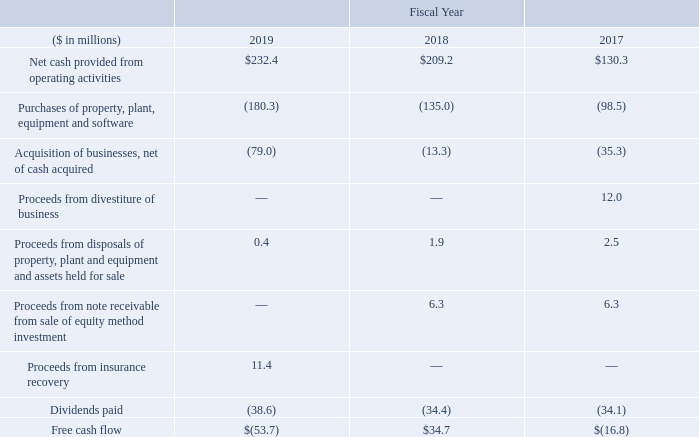Free Cash Flow
The following provides a reconciliation of free cash flow, as used in this annual report, to its most directly comparable U.S. GAAP financial measures:
Management believes that the free cash flow measure provides useful information to investors regarding our financial condition because it is a measure of cash generated which management evaluates for alternative uses. It is management’s current intention to use excess cash to fund investments in capital equipment, acquisition opportunities and consistent dividend payments. Free cash flow is not a U.S. GAAP financial measure and should not be considered in isolation of, or as a substitute for, cash flows calculated in accordance with U.S. GAAP.
What was the Proceeds from insurance recovery in 2019?
Answer scale should be: million. 11.4. What does management believe the free cash flow measure provides? Useful information to investors regarding our financial condition because it is a measure of cash generated which management evaluates for alternative uses. In which years was free cash flow calculated? 2019, 2018, 2017. In which year was the Proceeds from disposals of property, plant and equipment and assets held for sale largest? 2.5>1.9>0.4
Answer: 2017. What was the change in Net cash provided from operating activities in 2019 from 2018?
Answer scale should be: million. 232.4-209.2
Answer: 23.2. What was the percentage change in Net cash provided from operating activities in 2019 from 2018?
Answer scale should be: percent. (232.4-209.2)/209.2
Answer: 11.09. 